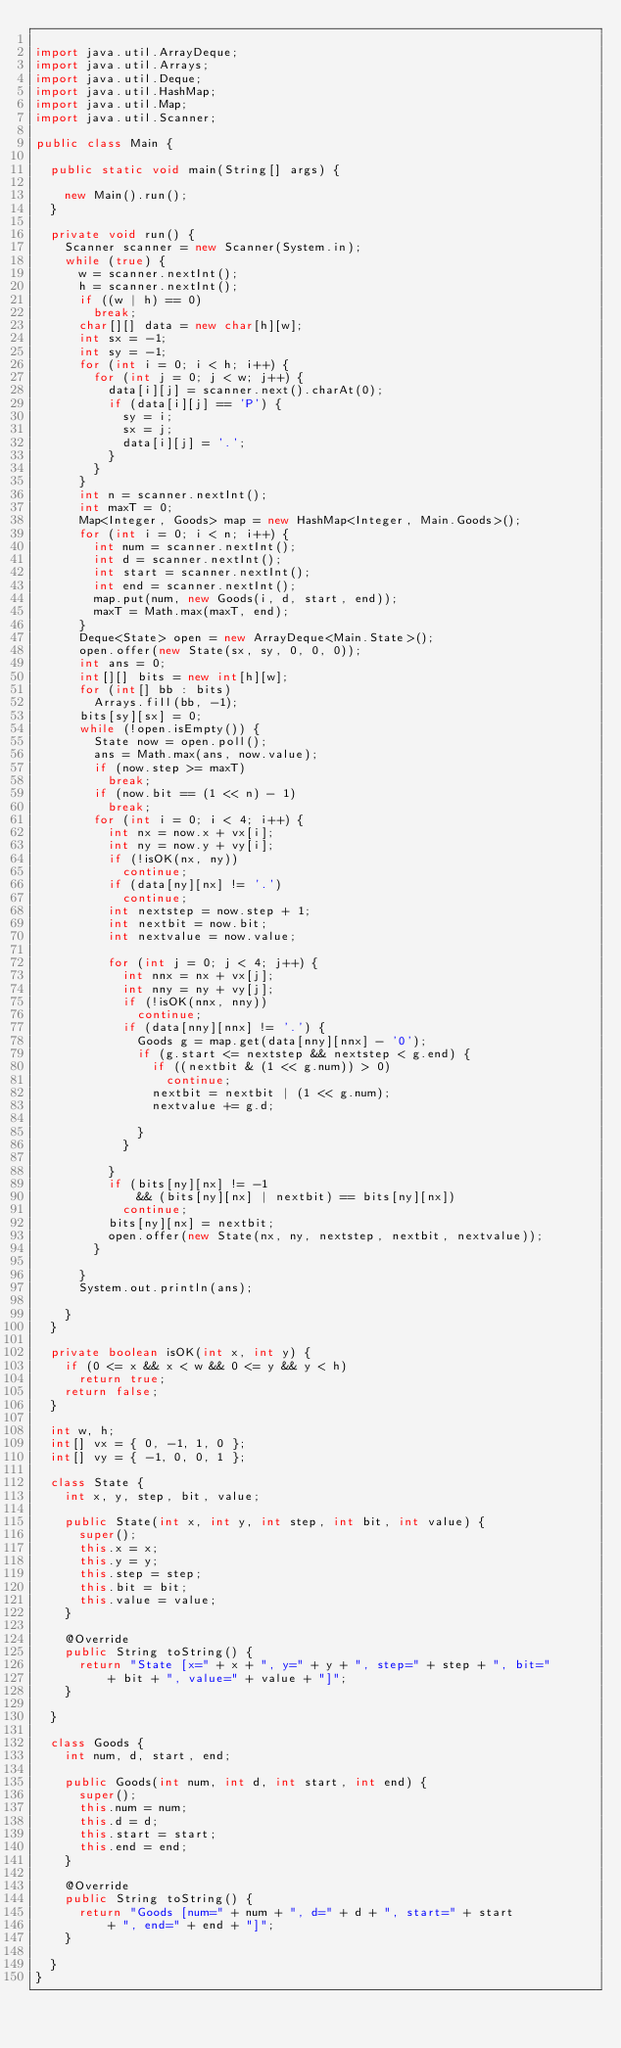<code> <loc_0><loc_0><loc_500><loc_500><_Java_>
import java.util.ArrayDeque;
import java.util.Arrays;
import java.util.Deque;
import java.util.HashMap;
import java.util.Map;
import java.util.Scanner;

public class Main {

	public static void main(String[] args) {

		new Main().run();
	}

	private void run() {
		Scanner scanner = new Scanner(System.in);
		while (true) {
			w = scanner.nextInt();
			h = scanner.nextInt();
			if ((w | h) == 0)
				break;
			char[][] data = new char[h][w];
			int sx = -1;
			int sy = -1;
			for (int i = 0; i < h; i++) {
				for (int j = 0; j < w; j++) {
					data[i][j] = scanner.next().charAt(0);
					if (data[i][j] == 'P') {
						sy = i;
						sx = j;
						data[i][j] = '.';
					}
				}
			}
			int n = scanner.nextInt();
			int maxT = 0;
			Map<Integer, Goods> map = new HashMap<Integer, Main.Goods>();
			for (int i = 0; i < n; i++) {
				int num = scanner.nextInt();
				int d = scanner.nextInt();
				int start = scanner.nextInt();
				int end = scanner.nextInt();
				map.put(num, new Goods(i, d, start, end));
				maxT = Math.max(maxT, end);
			}
			Deque<State> open = new ArrayDeque<Main.State>();
			open.offer(new State(sx, sy, 0, 0, 0));
			int ans = 0;
			int[][] bits = new int[h][w];
			for (int[] bb : bits)
				Arrays.fill(bb, -1);
			bits[sy][sx] = 0;
			while (!open.isEmpty()) {
				State now = open.poll();
				ans = Math.max(ans, now.value);
				if (now.step >= maxT)
					break;
				if (now.bit == (1 << n) - 1)
					break;
				for (int i = 0; i < 4; i++) {
					int nx = now.x + vx[i];
					int ny = now.y + vy[i];
					if (!isOK(nx, ny))
						continue;
					if (data[ny][nx] != '.')
						continue;
					int nextstep = now.step + 1;
					int nextbit = now.bit;
					int nextvalue = now.value;

					for (int j = 0; j < 4; j++) {
						int nnx = nx + vx[j];
						int nny = ny + vy[j];
						if (!isOK(nnx, nny))
							continue;
						if (data[nny][nnx] != '.') {
							Goods g = map.get(data[nny][nnx] - '0');
							if (g.start <= nextstep && nextstep < g.end) {
								if ((nextbit & (1 << g.num)) > 0)
									continue;
								nextbit = nextbit | (1 << g.num);
								nextvalue += g.d;

							}
						}

					}
					if (bits[ny][nx] != -1
							&& (bits[ny][nx] | nextbit) == bits[ny][nx])
						continue;
					bits[ny][nx] = nextbit;
					open.offer(new State(nx, ny, nextstep, nextbit, nextvalue));
				}

			}
			System.out.println(ans);

		}
	}

	private boolean isOK(int x, int y) {
		if (0 <= x && x < w && 0 <= y && y < h)
			return true;
		return false;
	}

	int w, h;
	int[] vx = { 0, -1, 1, 0 };
	int[] vy = { -1, 0, 0, 1 };

	class State {
		int x, y, step, bit, value;

		public State(int x, int y, int step, int bit, int value) {
			super();
			this.x = x;
			this.y = y;
			this.step = step;
			this.bit = bit;
			this.value = value;
		}

		@Override
		public String toString() {
			return "State [x=" + x + ", y=" + y + ", step=" + step + ", bit="
					+ bit + ", value=" + value + "]";
		}

	}

	class Goods {
		int num, d, start, end;

		public Goods(int num, int d, int start, int end) {
			super();
			this.num = num;
			this.d = d;
			this.start = start;
			this.end = end;
		}

		@Override
		public String toString() {
			return "Goods [num=" + num + ", d=" + d + ", start=" + start
					+ ", end=" + end + "]";
		}

	}
}</code> 